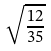Convert formula to latex. <formula><loc_0><loc_0><loc_500><loc_500>\sqrt { \frac { 1 2 } { 3 5 } }</formula> 